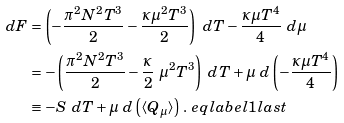<formula> <loc_0><loc_0><loc_500><loc_500>d F & = \left ( - \frac { \pi ^ { 2 } N ^ { 2 } T ^ { 3 } } { 2 } - \frac { \kappa \mu ^ { 2 } T ^ { 3 } } { 2 } \right ) \ d T - \frac { \kappa \mu T ^ { 4 } } { 4 } \ d \mu \\ & = - \left ( \frac { \pi ^ { 2 } N ^ { 2 } T ^ { 3 } } { 2 } - \frac { \kappa } { 2 } \ \mu ^ { 2 } T ^ { 3 } \right ) \ d T + \mu \ d \left ( - \frac { \kappa \mu T ^ { 4 } } { 4 } \right ) \\ & \equiv - S \ d T + \mu \ d \left ( \langle Q _ { \mu } \rangle \right ) \, . \ e q l a b e l { 1 l a s t }</formula> 